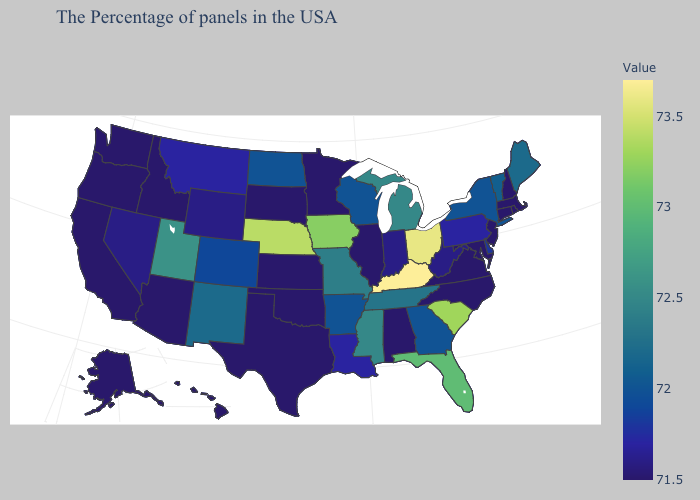Does Mississippi have a higher value than Delaware?
Give a very brief answer. Yes. Among the states that border Arizona , does Colorado have the highest value?
Keep it brief. No. Does Nebraska have a lower value than Kentucky?
Short answer required. Yes. Does Utah have the highest value in the West?
Concise answer only. Yes. Does Utah have the highest value in the West?
Write a very short answer. Yes. Which states have the lowest value in the USA?
Short answer required. Massachusetts, Rhode Island, New Hampshire, Connecticut, New Jersey, Maryland, Virginia, North Carolina, Alabama, Illinois, Minnesota, Kansas, Oklahoma, Texas, South Dakota, Arizona, Idaho, California, Washington, Oregon, Alaska, Hawaii. 